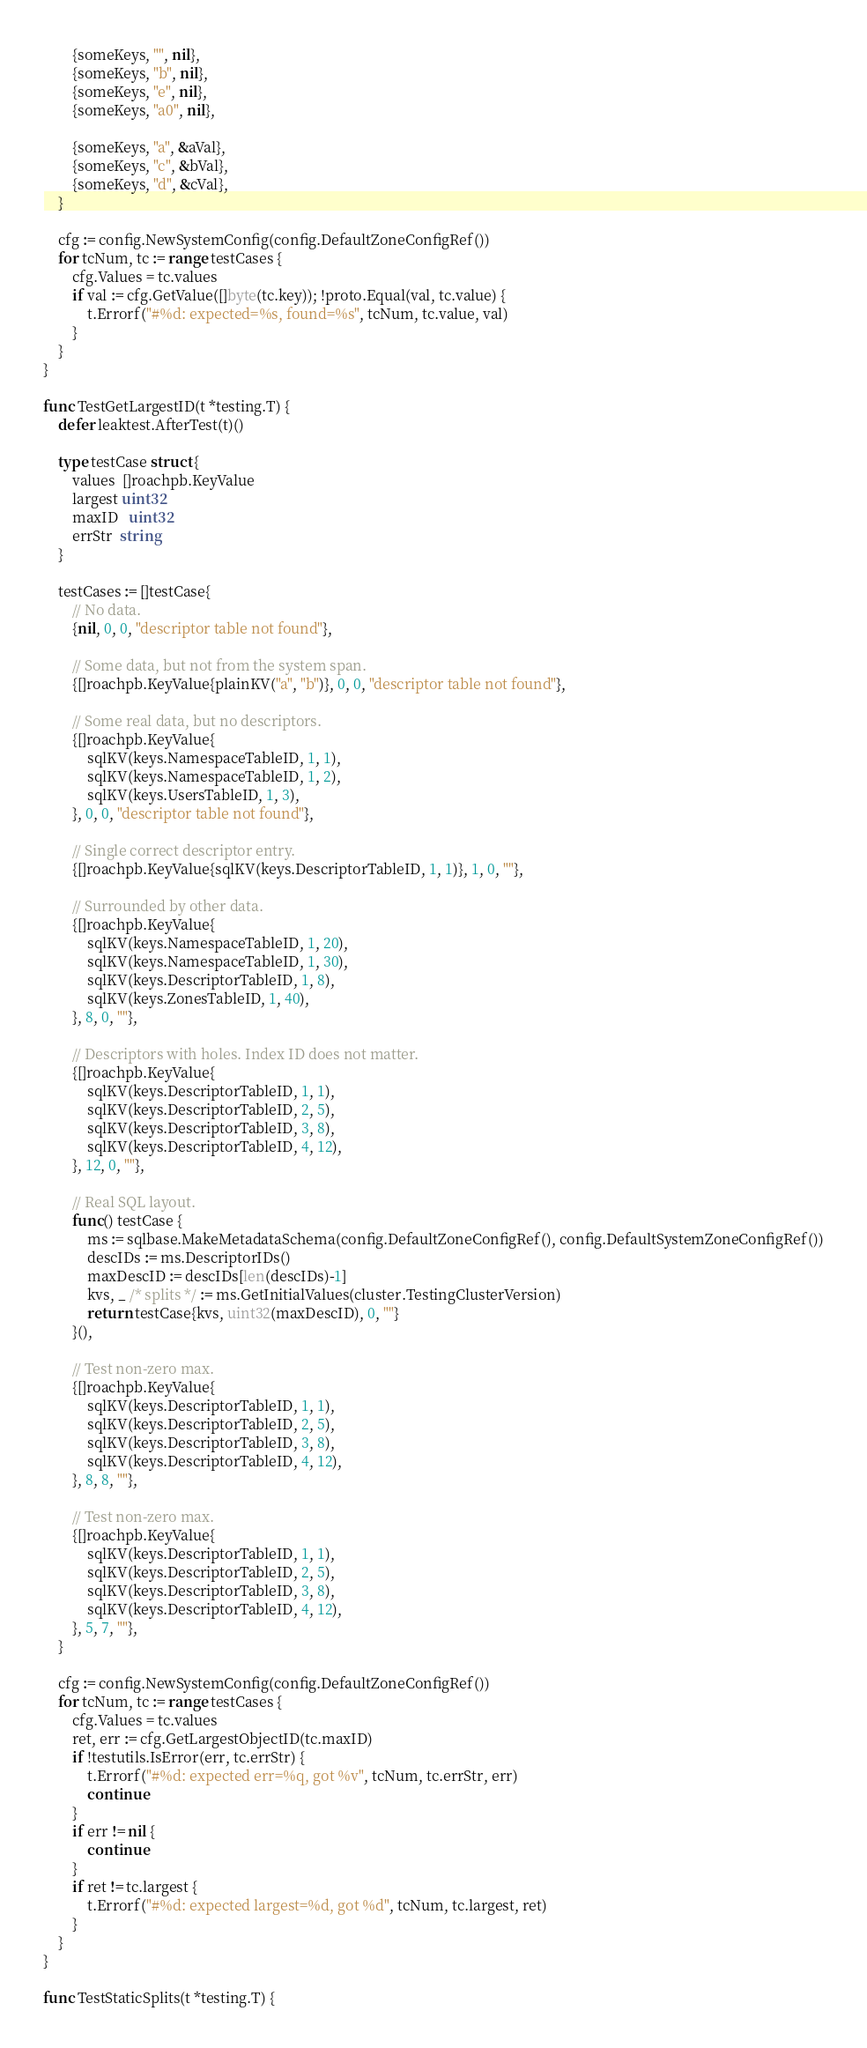Convert code to text. <code><loc_0><loc_0><loc_500><loc_500><_Go_>
		{someKeys, "", nil},
		{someKeys, "b", nil},
		{someKeys, "e", nil},
		{someKeys, "a0", nil},

		{someKeys, "a", &aVal},
		{someKeys, "c", &bVal},
		{someKeys, "d", &cVal},
	}

	cfg := config.NewSystemConfig(config.DefaultZoneConfigRef())
	for tcNum, tc := range testCases {
		cfg.Values = tc.values
		if val := cfg.GetValue([]byte(tc.key)); !proto.Equal(val, tc.value) {
			t.Errorf("#%d: expected=%s, found=%s", tcNum, tc.value, val)
		}
	}
}

func TestGetLargestID(t *testing.T) {
	defer leaktest.AfterTest(t)()

	type testCase struct {
		values  []roachpb.KeyValue
		largest uint32
		maxID   uint32
		errStr  string
	}

	testCases := []testCase{
		// No data.
		{nil, 0, 0, "descriptor table not found"},

		// Some data, but not from the system span.
		{[]roachpb.KeyValue{plainKV("a", "b")}, 0, 0, "descriptor table not found"},

		// Some real data, but no descriptors.
		{[]roachpb.KeyValue{
			sqlKV(keys.NamespaceTableID, 1, 1),
			sqlKV(keys.NamespaceTableID, 1, 2),
			sqlKV(keys.UsersTableID, 1, 3),
		}, 0, 0, "descriptor table not found"},

		// Single correct descriptor entry.
		{[]roachpb.KeyValue{sqlKV(keys.DescriptorTableID, 1, 1)}, 1, 0, ""},

		// Surrounded by other data.
		{[]roachpb.KeyValue{
			sqlKV(keys.NamespaceTableID, 1, 20),
			sqlKV(keys.NamespaceTableID, 1, 30),
			sqlKV(keys.DescriptorTableID, 1, 8),
			sqlKV(keys.ZonesTableID, 1, 40),
		}, 8, 0, ""},

		// Descriptors with holes. Index ID does not matter.
		{[]roachpb.KeyValue{
			sqlKV(keys.DescriptorTableID, 1, 1),
			sqlKV(keys.DescriptorTableID, 2, 5),
			sqlKV(keys.DescriptorTableID, 3, 8),
			sqlKV(keys.DescriptorTableID, 4, 12),
		}, 12, 0, ""},

		// Real SQL layout.
		func() testCase {
			ms := sqlbase.MakeMetadataSchema(config.DefaultZoneConfigRef(), config.DefaultSystemZoneConfigRef())
			descIDs := ms.DescriptorIDs()
			maxDescID := descIDs[len(descIDs)-1]
			kvs, _ /* splits */ := ms.GetInitialValues(cluster.TestingClusterVersion)
			return testCase{kvs, uint32(maxDescID), 0, ""}
		}(),

		// Test non-zero max.
		{[]roachpb.KeyValue{
			sqlKV(keys.DescriptorTableID, 1, 1),
			sqlKV(keys.DescriptorTableID, 2, 5),
			sqlKV(keys.DescriptorTableID, 3, 8),
			sqlKV(keys.DescriptorTableID, 4, 12),
		}, 8, 8, ""},

		// Test non-zero max.
		{[]roachpb.KeyValue{
			sqlKV(keys.DescriptorTableID, 1, 1),
			sqlKV(keys.DescriptorTableID, 2, 5),
			sqlKV(keys.DescriptorTableID, 3, 8),
			sqlKV(keys.DescriptorTableID, 4, 12),
		}, 5, 7, ""},
	}

	cfg := config.NewSystemConfig(config.DefaultZoneConfigRef())
	for tcNum, tc := range testCases {
		cfg.Values = tc.values
		ret, err := cfg.GetLargestObjectID(tc.maxID)
		if !testutils.IsError(err, tc.errStr) {
			t.Errorf("#%d: expected err=%q, got %v", tcNum, tc.errStr, err)
			continue
		}
		if err != nil {
			continue
		}
		if ret != tc.largest {
			t.Errorf("#%d: expected largest=%d, got %d", tcNum, tc.largest, ret)
		}
	}
}

func TestStaticSplits(t *testing.T) {</code> 